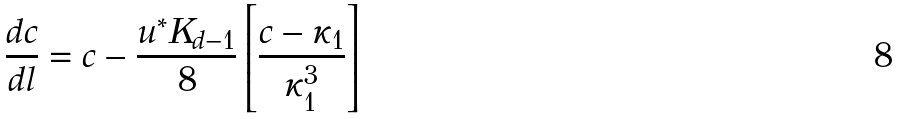Convert formula to latex. <formula><loc_0><loc_0><loc_500><loc_500>\frac { d c } { d l } = c - \frac { u ^ { * } K _ { d - 1 } } { 8 } \left [ \frac { c - \kappa _ { 1 } } { \kappa _ { 1 } ^ { 3 } } \right ]</formula> 